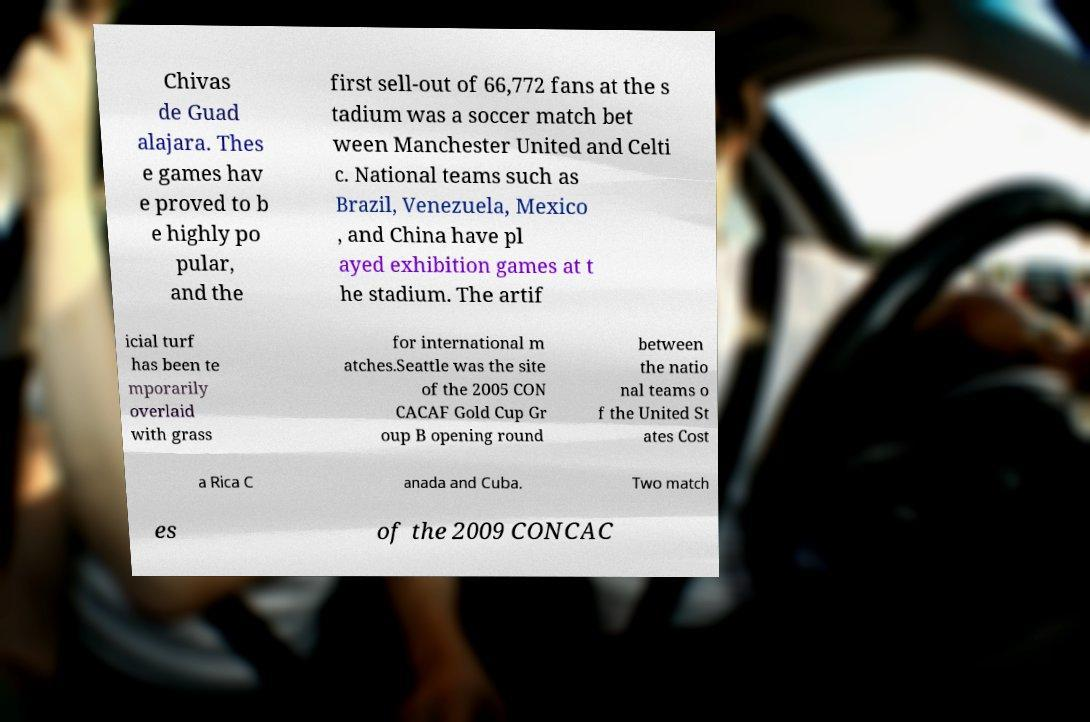What messages or text are displayed in this image? I need them in a readable, typed format. Chivas de Guad alajara. Thes e games hav e proved to b e highly po pular, and the first sell-out of 66,772 fans at the s tadium was a soccer match bet ween Manchester United and Celti c. National teams such as Brazil, Venezuela, Mexico , and China have pl ayed exhibition games at t he stadium. The artif icial turf has been te mporarily overlaid with grass for international m atches.Seattle was the site of the 2005 CON CACAF Gold Cup Gr oup B opening round between the natio nal teams o f the United St ates Cost a Rica C anada and Cuba. Two match es of the 2009 CONCAC 